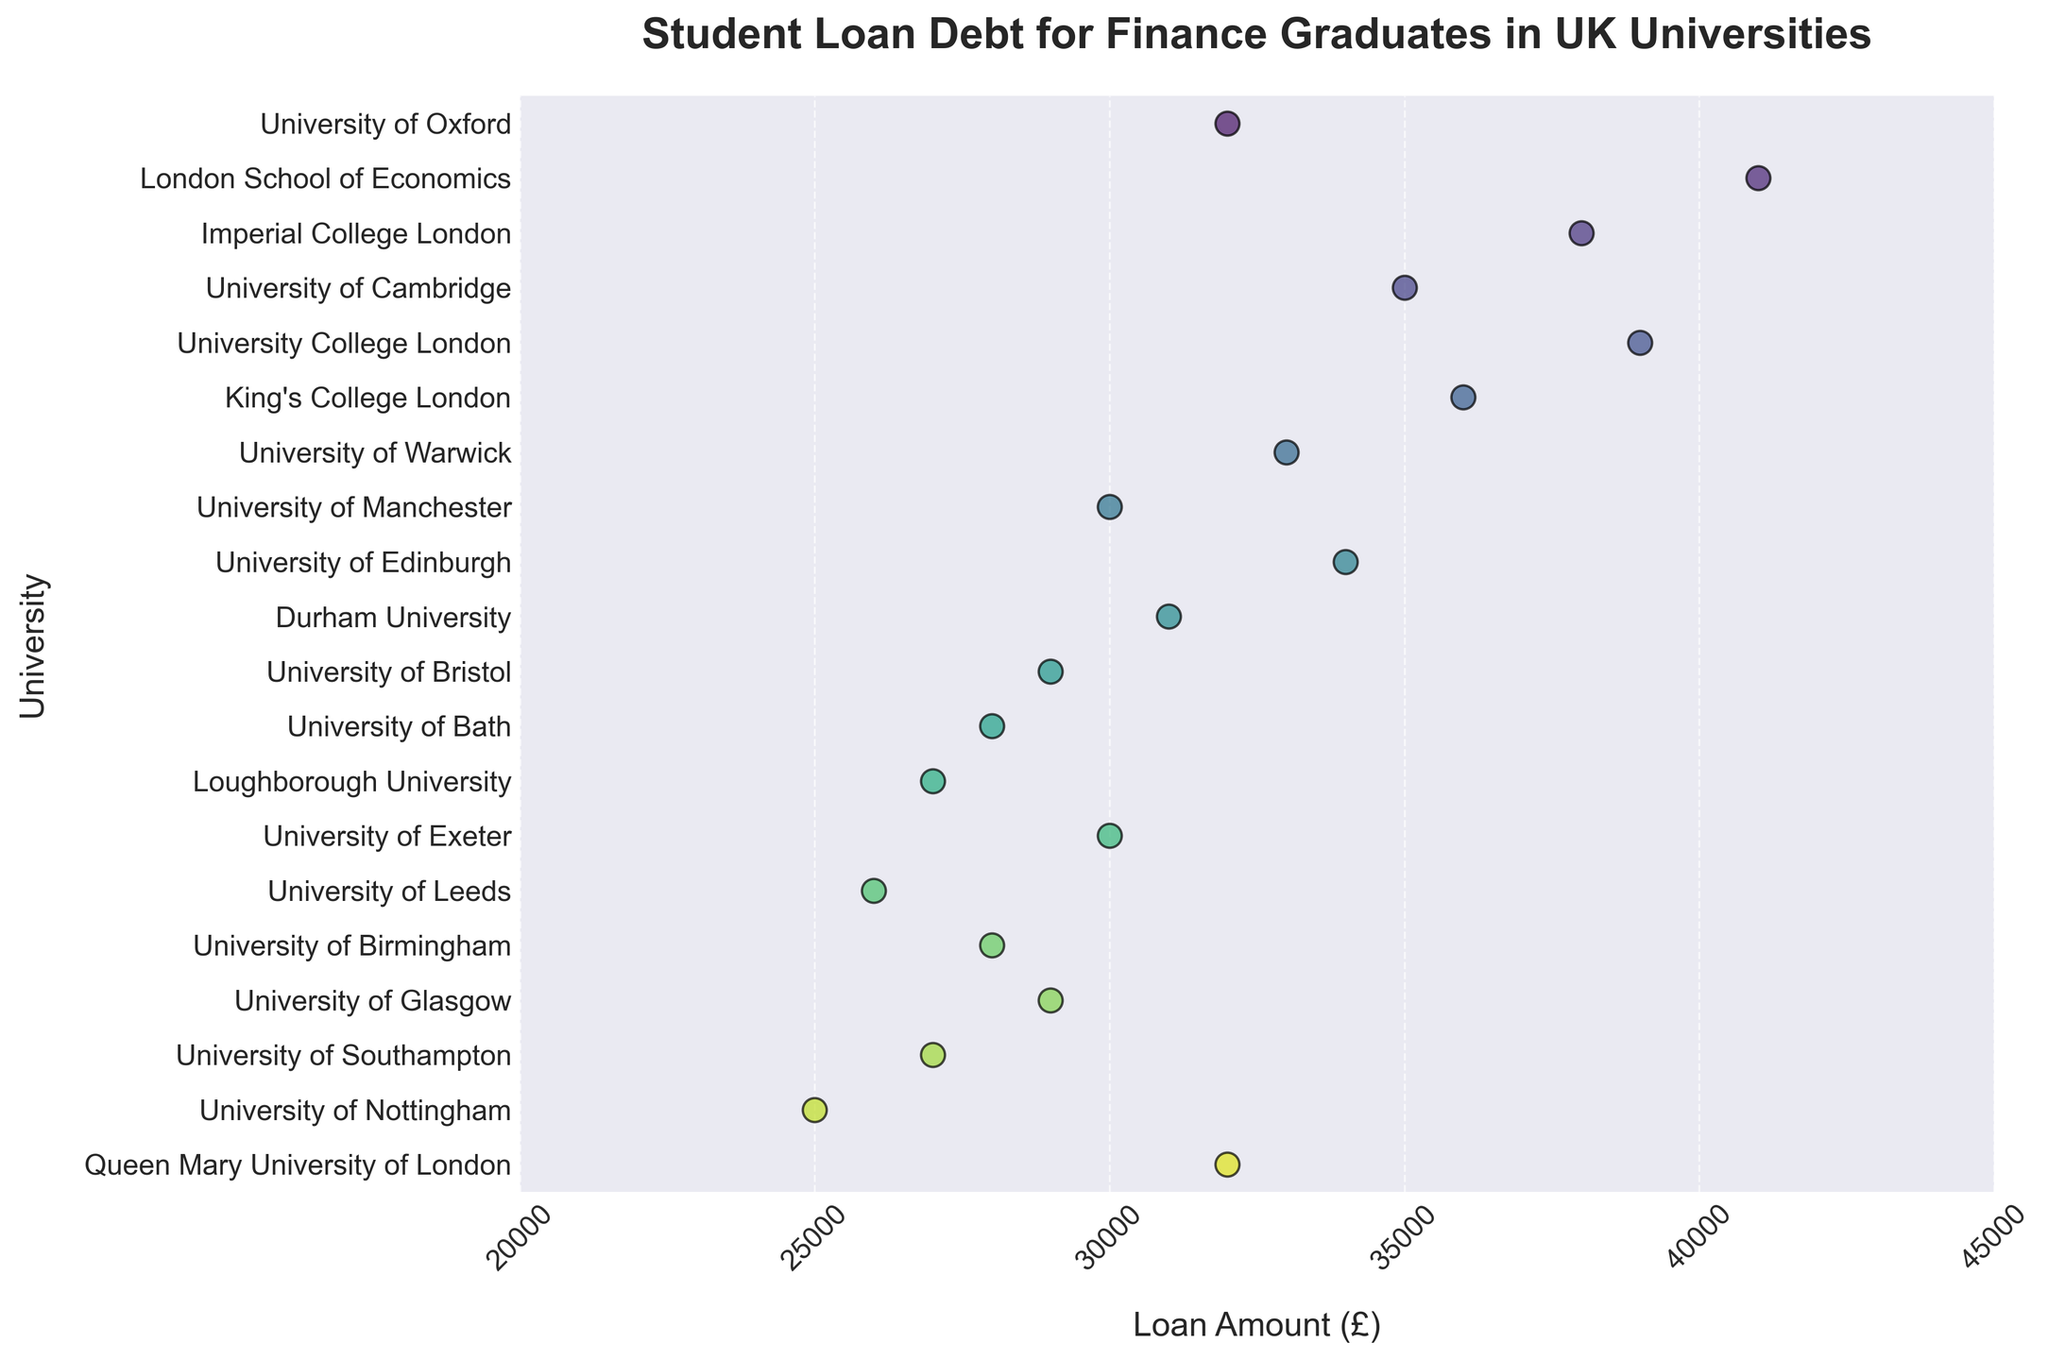What's the title of the figure? The title is usually located at the top of the figure and summarizes what the figure is about.
Answer: Student Loan Debt for Finance Graduates in UK Universities Which university has the highest student loan amount? Look at the plot and identify the highest data point among all universities.
Answer: London School of Economics What's the range of student loan amounts? The range can be determined by finding the difference between the maximum and minimum loan amounts. The max is £41000, and the min is £25000.
Answer: £16000 How many universities have a loan amount above £35,000? Count the number of data points above the £35,000 mark. These are University of Oxford, London School of Economics, Imperial College London, University College London, King's College London, and University of Cambridge.
Answer: 6 What's the average loan amount for the universities shown? Sum all the loan amounts and divide by the number of universities. Total loan amount: 32000+41000+38000+35000+39000+36000+33000+30000+34000+31000+29000+28000+27000+30000+26000+28000+29000+27000+25000+32000 = £609000. Number of universities: 20. Average loan amount = 609000/20.
Answer: £30450 Which universities have loan amounts less than £30,000? Identify the universities with data points below the £30,000 mark. These are University of Bristol, University of Bath, Loughborough University, University of Leeds, University of Birmingham, University of Glasgow, University of Southampton, and University of Nottingham.
Answer: 8 Is the loan amount for University College London higher than University of Glasgow? Compare the loan amounts of University College London (£39000) and University of Glasgow (£29000).
Answer: Yes What's the median student loan amount? To find the median, list all loan amounts in ascending order and find the middle value(s). Order: 25000, 26000, 27000, 27000, 28000, 28000, 29000, 29000, 30000, 30000, 31000, 32000, 32000, 33000, 34000, 35000, 36000, 38000, 39000, 41000. Median = (30000+31000)/2.
Answer: £30500 